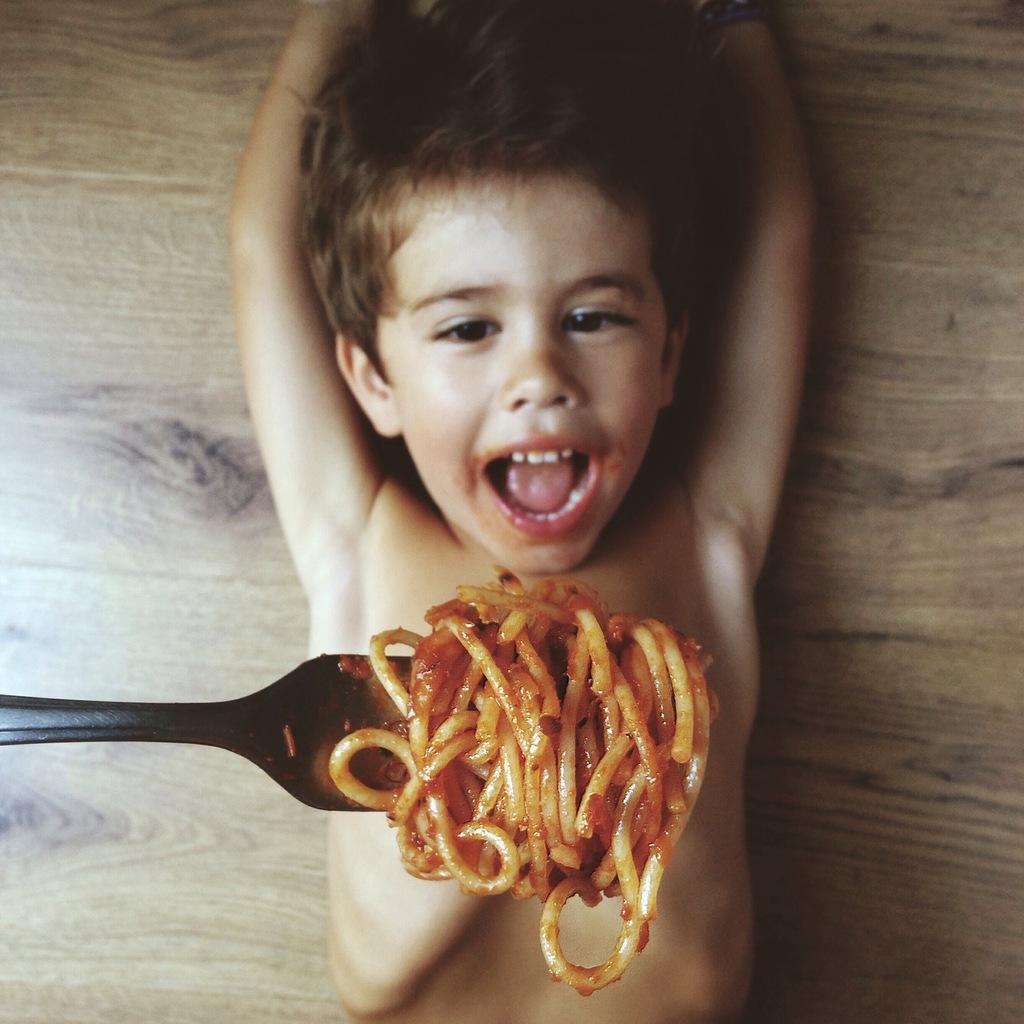Who is the main subject in the image? There is a boy in the image. What is the boy doing in the image? The boy is lying on a table. What food item can be seen in the image? There is a fork with noodles in the image. What type of glue is the boy using to stick the religious symbols on the sidewalk in the image? There is no glue, religious symbols, or sidewalk present in the image. 